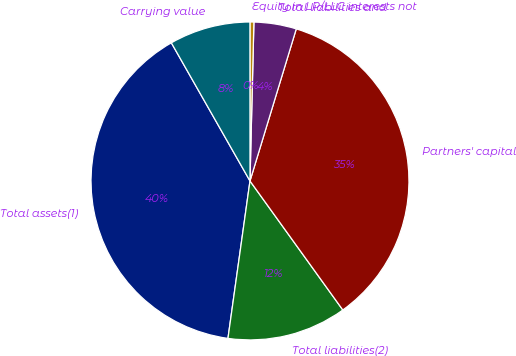Convert chart. <chart><loc_0><loc_0><loc_500><loc_500><pie_chart><fcel>Total assets(1)<fcel>Total liabilities(2)<fcel>Partners' capital<fcel>Total liabilities and<fcel>Equity in LP/LLC interests not<fcel>Carrying value<nl><fcel>39.55%<fcel>12.14%<fcel>35.37%<fcel>4.31%<fcel>0.4%<fcel>8.23%<nl></chart> 